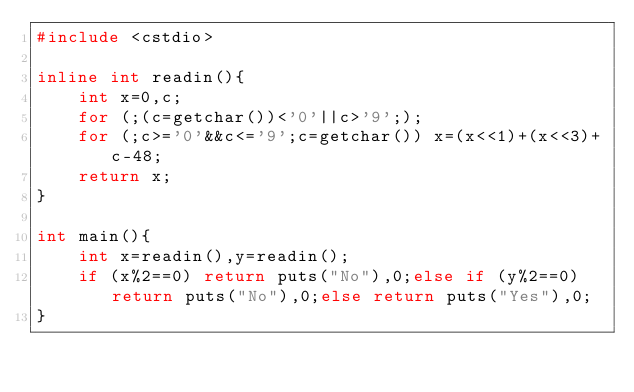<code> <loc_0><loc_0><loc_500><loc_500><_C++_>#include <cstdio>

inline int readin(){
	int x=0,c;
	for (;(c=getchar())<'0'||c>'9';);
	for (;c>='0'&&c<='9';c=getchar()) x=(x<<1)+(x<<3)+c-48;
	return x;
}

int main(){
	int x=readin(),y=readin();
	if (x%2==0) return puts("No"),0;else if (y%2==0) return puts("No"),0;else return puts("Yes"),0;
}</code> 